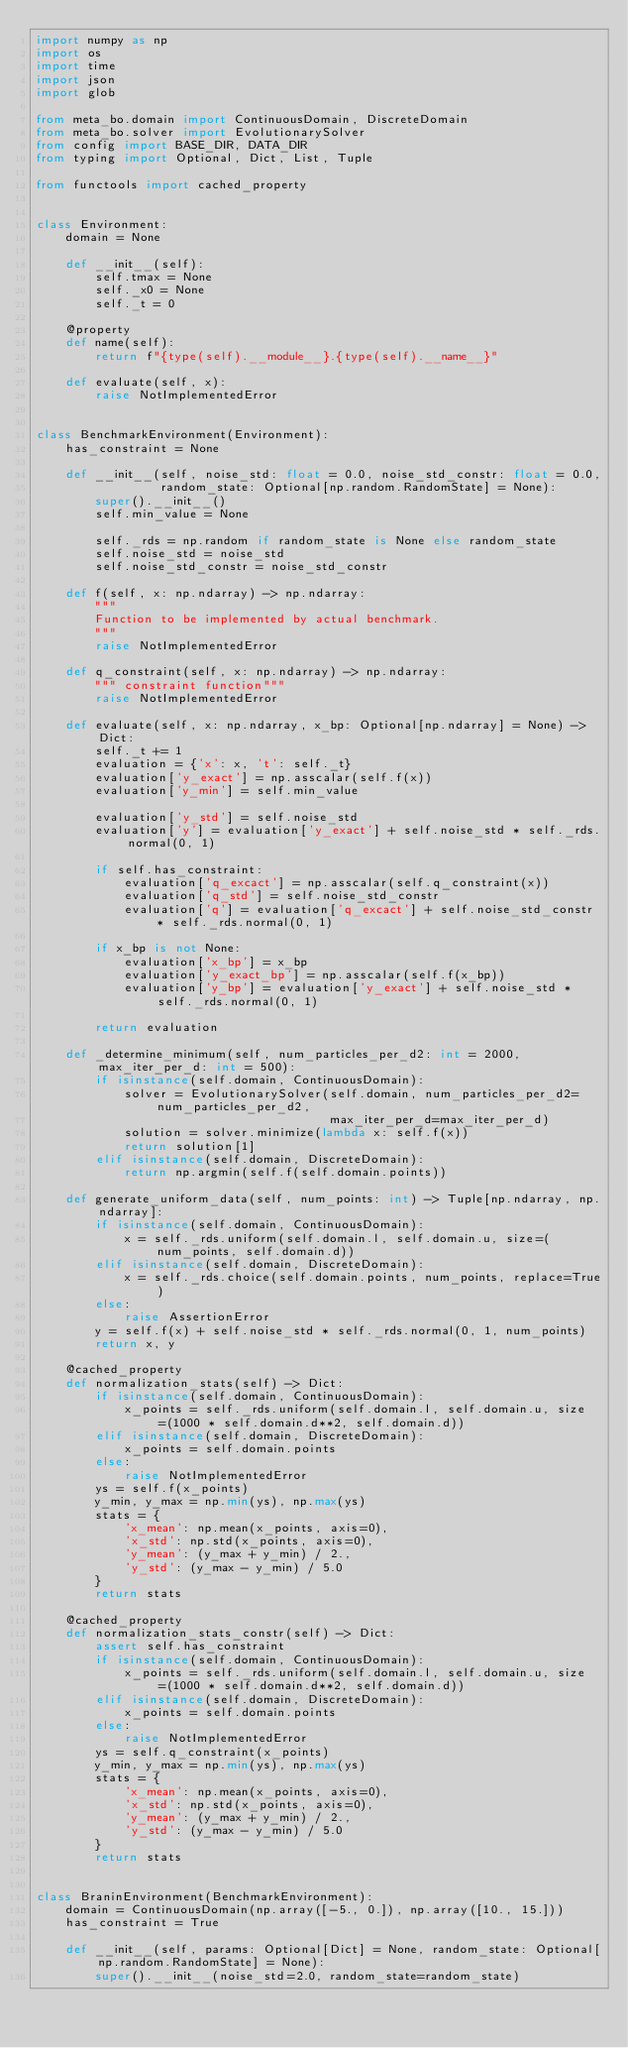Convert code to text. <code><loc_0><loc_0><loc_500><loc_500><_Python_>import numpy as np
import os
import time
import json
import glob

from meta_bo.domain import ContinuousDomain, DiscreteDomain
from meta_bo.solver import EvolutionarySolver
from config import BASE_DIR, DATA_DIR
from typing import Optional, Dict, List, Tuple

from functools import cached_property


class Environment:
    domain = None

    def __init__(self):
        self.tmax = None
        self._x0 = None
        self._t = 0

    @property
    def name(self):
        return f"{type(self).__module__}.{type(self).__name__}"

    def evaluate(self, x):
        raise NotImplementedError


class BenchmarkEnvironment(Environment):
    has_constraint = None

    def __init__(self, noise_std: float = 0.0, noise_std_constr: float = 0.0,
                 random_state: Optional[np.random.RandomState] = None):
        super().__init__()
        self.min_value = None

        self._rds = np.random if random_state is None else random_state
        self.noise_std = noise_std
        self.noise_std_constr = noise_std_constr

    def f(self, x: np.ndarray) -> np.ndarray:
        """
        Function to be implemented by actual benchmark.
        """
        raise NotImplementedError

    def q_constraint(self, x: np.ndarray) -> np.ndarray:
        """ constraint function"""
        raise NotImplementedError

    def evaluate(self, x: np.ndarray, x_bp: Optional[np.ndarray] = None) -> Dict:
        self._t += 1
        evaluation = {'x': x, 't': self._t}
        evaluation['y_exact'] = np.asscalar(self.f(x))
        evaluation['y_min'] = self.min_value

        evaluation['y_std'] = self.noise_std
        evaluation['y'] = evaluation['y_exact'] + self.noise_std * self._rds.normal(0, 1)

        if self.has_constraint:
            evaluation['q_excact'] = np.asscalar(self.q_constraint(x))
            evaluation['q_std'] = self.noise_std_constr
            evaluation['q'] = evaluation['q_excact'] + self.noise_std_constr * self._rds.normal(0, 1)

        if x_bp is not None:
            evaluation['x_bp'] = x_bp
            evaluation['y_exact_bp'] = np.asscalar(self.f(x_bp))
            evaluation['y_bp'] = evaluation['y_exact'] + self.noise_std * self._rds.normal(0, 1)

        return evaluation

    def _determine_minimum(self, num_particles_per_d2: int = 2000, max_iter_per_d: int = 500):
        if isinstance(self.domain, ContinuousDomain):
            solver = EvolutionarySolver(self.domain, num_particles_per_d2=num_particles_per_d2,
                                        max_iter_per_d=max_iter_per_d)
            solution = solver.minimize(lambda x: self.f(x))
            return solution[1]
        elif isinstance(self.domain, DiscreteDomain):
            return np.argmin(self.f(self.domain.points))

    def generate_uniform_data(self, num_points: int) -> Tuple[np.ndarray, np.ndarray]:
        if isinstance(self.domain, ContinuousDomain):
            x = self._rds.uniform(self.domain.l, self.domain.u, size=(num_points, self.domain.d))
        elif isinstance(self.domain, DiscreteDomain):
            x = self._rds.choice(self.domain.points, num_points, replace=True)
        else:
            raise AssertionError
        y = self.f(x) + self.noise_std * self._rds.normal(0, 1, num_points)
        return x, y

    @cached_property
    def normalization_stats(self) -> Dict:
        if isinstance(self.domain, ContinuousDomain):
            x_points = self._rds.uniform(self.domain.l, self.domain.u, size=(1000 * self.domain.d**2, self.domain.d))
        elif isinstance(self.domain, DiscreteDomain):
            x_points = self.domain.points
        else:
            raise NotImplementedError
        ys = self.f(x_points)
        y_min, y_max = np.min(ys), np.max(ys)
        stats = {
            'x_mean': np.mean(x_points, axis=0),
            'x_std': np.std(x_points, axis=0),
            'y_mean': (y_max + y_min) / 2.,
            'y_std': (y_max - y_min) / 5.0
        }
        return stats

    @cached_property
    def normalization_stats_constr(self) -> Dict:
        assert self.has_constraint
        if isinstance(self.domain, ContinuousDomain):
            x_points = self._rds.uniform(self.domain.l, self.domain.u, size=(1000 * self.domain.d**2, self.domain.d))
        elif isinstance(self.domain, DiscreteDomain):
            x_points = self.domain.points
        else:
            raise NotImplementedError
        ys = self.q_constraint(x_points)
        y_min, y_max = np.min(ys), np.max(ys)
        stats = {
            'x_mean': np.mean(x_points, axis=0),
            'x_std': np.std(x_points, axis=0),
            'y_mean': (y_max + y_min) / 2.,
            'y_std': (y_max - y_min) / 5.0
        }
        return stats


class BraninEnvironment(BenchmarkEnvironment):
    domain = ContinuousDomain(np.array([-5., 0.]), np.array([10., 15.]))
    has_constraint = True

    def __init__(self, params: Optional[Dict] = None, random_state: Optional[np.random.RandomState] = None):
        super().__init__(noise_std=2.0, random_state=random_state)</code> 